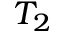<formula> <loc_0><loc_0><loc_500><loc_500>T _ { 2 }</formula> 